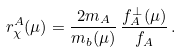<formula> <loc_0><loc_0><loc_500><loc_500>r _ { \chi } ^ { A } ( \mu ) = \frac { 2 m _ { A } } { m _ { b } ( \mu ) } \, \frac { f _ { A } ^ { \perp } ( \mu ) } { f _ { A } } \, .</formula> 